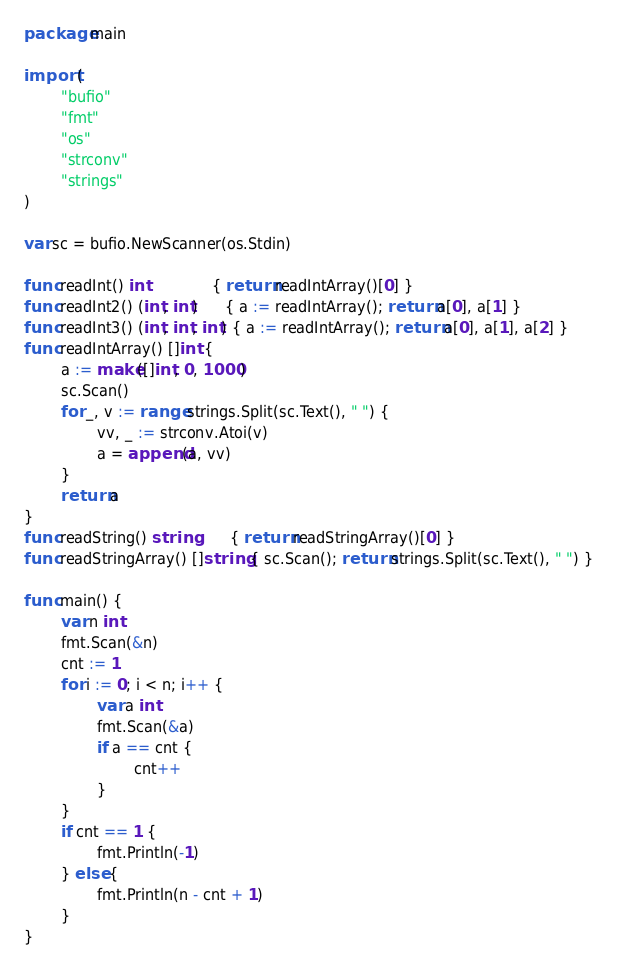<code> <loc_0><loc_0><loc_500><loc_500><_Go_>package main

import (
        "bufio"
        "fmt"
        "os"
        "strconv"
        "strings"
)

var sc = bufio.NewScanner(os.Stdin)

func readInt() int              { return readIntArray()[0] }
func readInt2() (int, int)      { a := readIntArray(); return a[0], a[1] }
func readInt3() (int, int, int) { a := readIntArray(); return a[0], a[1], a[2] }
func readIntArray() []int {
        a := make([]int, 0, 1000)
        sc.Scan()
        for _, v := range strings.Split(sc.Text(), " ") {
                vv, _ := strconv.Atoi(v)
                a = append(a, vv)
        }
        return a
}
func readString() string        { return readStringArray()[0] }
func readStringArray() []string { sc.Scan(); return strings.Split(sc.Text(), " ") }

func main() {
        var n int
        fmt.Scan(&n)
        cnt := 1
        for i := 0; i < n; i++ {
                var a int
                fmt.Scan(&a)
                if a == cnt {
                        cnt++
                }
        }
        if cnt == 1 {
                fmt.Println(-1)
        } else {
                fmt.Println(n - cnt + 1)
        }
}</code> 